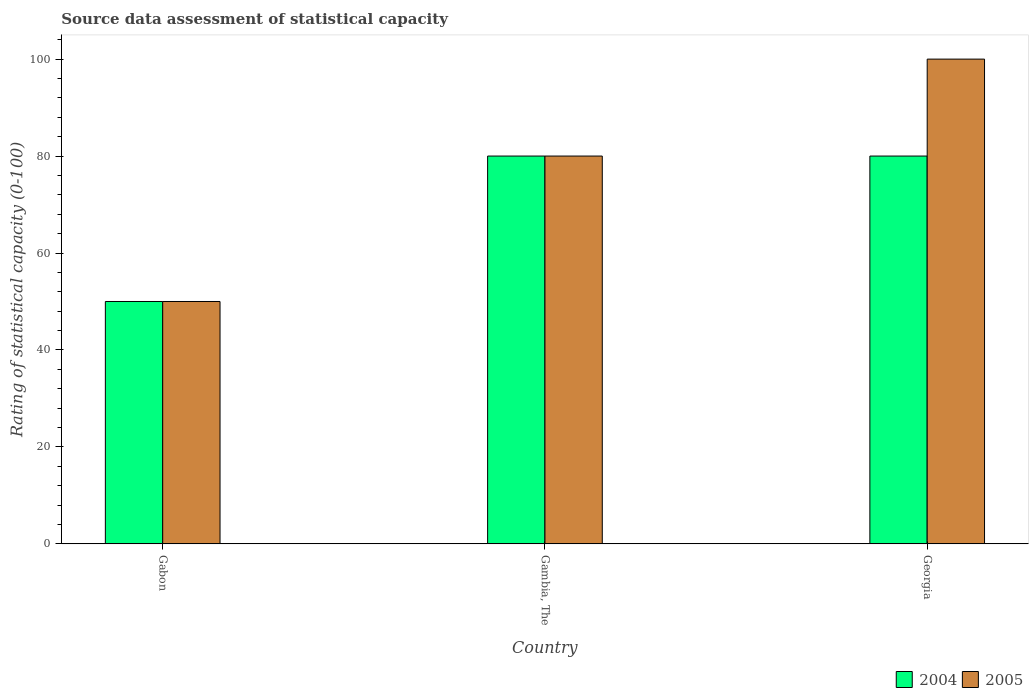How many different coloured bars are there?
Ensure brevity in your answer.  2. How many groups of bars are there?
Make the answer very short. 3. How many bars are there on the 3rd tick from the right?
Make the answer very short. 2. What is the label of the 2nd group of bars from the left?
Provide a succinct answer. Gambia, The. In which country was the rating of statistical capacity in 2005 maximum?
Make the answer very short. Georgia. In which country was the rating of statistical capacity in 2004 minimum?
Provide a succinct answer. Gabon. What is the total rating of statistical capacity in 2005 in the graph?
Ensure brevity in your answer.  230. What is the difference between the rating of statistical capacity in 2004 in Gabon and that in Georgia?
Your response must be concise. -30. What is the difference between the rating of statistical capacity in 2004 in Georgia and the rating of statistical capacity in 2005 in Gabon?
Your answer should be compact. 30. What is the average rating of statistical capacity in 2004 per country?
Give a very brief answer. 70. What is the difference between the rating of statistical capacity of/in 2005 and rating of statistical capacity of/in 2004 in Gambia, The?
Offer a very short reply. 0. In how many countries, is the rating of statistical capacity in 2005 greater than 84?
Your answer should be compact. 1. What is the ratio of the rating of statistical capacity in 2004 in Gambia, The to that in Georgia?
Make the answer very short. 1. What is the difference between the highest and the second highest rating of statistical capacity in 2005?
Ensure brevity in your answer.  30. What is the difference between the highest and the lowest rating of statistical capacity in 2004?
Ensure brevity in your answer.  30. In how many countries, is the rating of statistical capacity in 2005 greater than the average rating of statistical capacity in 2005 taken over all countries?
Offer a very short reply. 2. Is the sum of the rating of statistical capacity in 2004 in Gabon and Georgia greater than the maximum rating of statistical capacity in 2005 across all countries?
Make the answer very short. Yes. What does the 2nd bar from the left in Gambia, The represents?
Provide a short and direct response. 2005. What does the 2nd bar from the right in Gabon represents?
Your response must be concise. 2004. How many bars are there?
Offer a terse response. 6. What is the difference between two consecutive major ticks on the Y-axis?
Your response must be concise. 20. How are the legend labels stacked?
Provide a short and direct response. Horizontal. What is the title of the graph?
Provide a short and direct response. Source data assessment of statistical capacity. What is the label or title of the Y-axis?
Make the answer very short. Rating of statistical capacity (0-100). What is the Rating of statistical capacity (0-100) of 2004 in Gabon?
Your answer should be compact. 50. What is the Rating of statistical capacity (0-100) in 2005 in Gambia, The?
Give a very brief answer. 80. Across all countries, what is the maximum Rating of statistical capacity (0-100) of 2004?
Provide a short and direct response. 80. Across all countries, what is the minimum Rating of statistical capacity (0-100) in 2005?
Your response must be concise. 50. What is the total Rating of statistical capacity (0-100) of 2004 in the graph?
Make the answer very short. 210. What is the total Rating of statistical capacity (0-100) in 2005 in the graph?
Your answer should be compact. 230. What is the difference between the Rating of statistical capacity (0-100) in 2004 in Gabon and that in Gambia, The?
Your answer should be compact. -30. What is the difference between the Rating of statistical capacity (0-100) of 2004 in Gabon and that in Georgia?
Make the answer very short. -30. What is the difference between the Rating of statistical capacity (0-100) in 2005 in Gambia, The and that in Georgia?
Your response must be concise. -20. What is the difference between the Rating of statistical capacity (0-100) in 2004 in Gambia, The and the Rating of statistical capacity (0-100) in 2005 in Georgia?
Your answer should be compact. -20. What is the average Rating of statistical capacity (0-100) in 2005 per country?
Ensure brevity in your answer.  76.67. What is the ratio of the Rating of statistical capacity (0-100) of 2004 in Gabon to that in Gambia, The?
Give a very brief answer. 0.62. What is the ratio of the Rating of statistical capacity (0-100) of 2004 in Gabon to that in Georgia?
Provide a succinct answer. 0.62. What is the difference between the highest and the second highest Rating of statistical capacity (0-100) in 2005?
Provide a short and direct response. 20. What is the difference between the highest and the lowest Rating of statistical capacity (0-100) of 2005?
Keep it short and to the point. 50. 